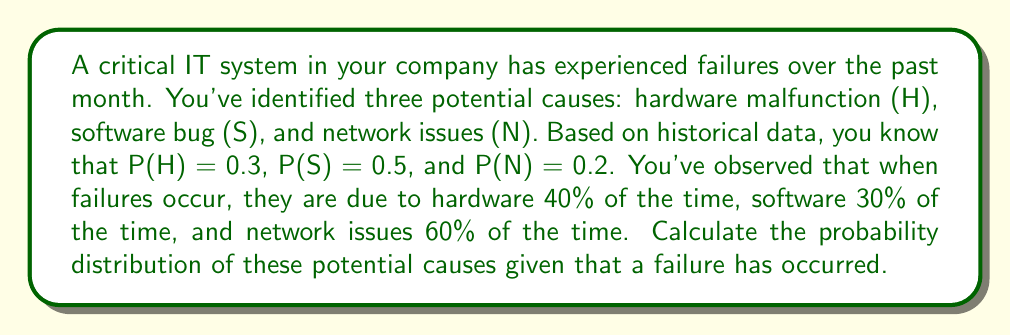Show me your answer to this math problem. To solve this inverse problem, we'll use Bayes' theorem to calculate the posterior probability for each cause given that a failure has occurred.

Let F denote the event of a system failure.

Given:
P(H) = 0.3, P(S) = 0.5, P(N) = 0.2
P(F|H) = 0.4, P(F|S) = 0.3, P(F|N) = 0.6

Step 1: Calculate P(F) using the law of total probability
$$ P(F) = P(F|H)P(H) + P(F|S)P(S) + P(F|N)P(N) $$
$$ P(F) = 0.4 \cdot 0.3 + 0.3 \cdot 0.5 + 0.6 \cdot 0.2 = 0.39 $$

Step 2: Use Bayes' theorem to calculate P(H|F)
$$ P(H|F) = \frac{P(F|H)P(H)}{P(F)} = \frac{0.4 \cdot 0.3}{0.39} \approx 0.3077 $$

Step 3: Calculate P(S|F)
$$ P(S|F) = \frac{P(F|S)P(S)}{P(F)} = \frac{0.3 \cdot 0.5}{0.39} \approx 0.3846 $$

Step 4: Calculate P(N|F)
$$ P(N|F) = \frac{P(F|N)P(N)}{P(F)} = \frac{0.6 \cdot 0.2}{0.39} \approx 0.3077 $$

Step 5: Verify that the probabilities sum to 1
$$ P(H|F) + P(S|F) + P(N|F) \approx 0.3077 + 0.3846 + 0.3077 = 1 $$

The probability distribution of potential causes given a failure has occurred is:
Hardware malfunction: 30.77%
Software bug: 38.46%
Network issues: 30.77%
Answer: P(H|F) ≈ 0.3077, P(S|F) ≈ 0.3846, P(N|F) ≈ 0.3077 